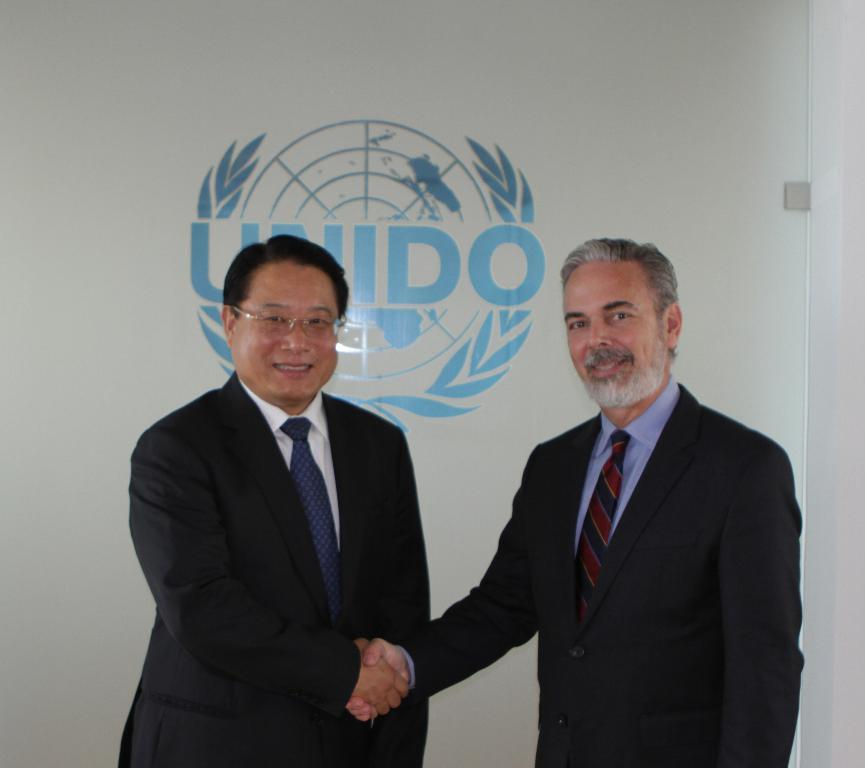How many people are in the image? There are two men in the image. What are the men wearing? The men are wearing suits. What are the men doing in the image? The men are holding hands and smiling. What can be seen in the background of the image? There is a banner in the background of the image. What type of beetle can be seen crawling on the banner in the image? There is no beetle present on the banner in the image. What flavor of mint is being used to freshen the men's breath in the image? There is no mention of mint or any breath freshening activity in the image. 